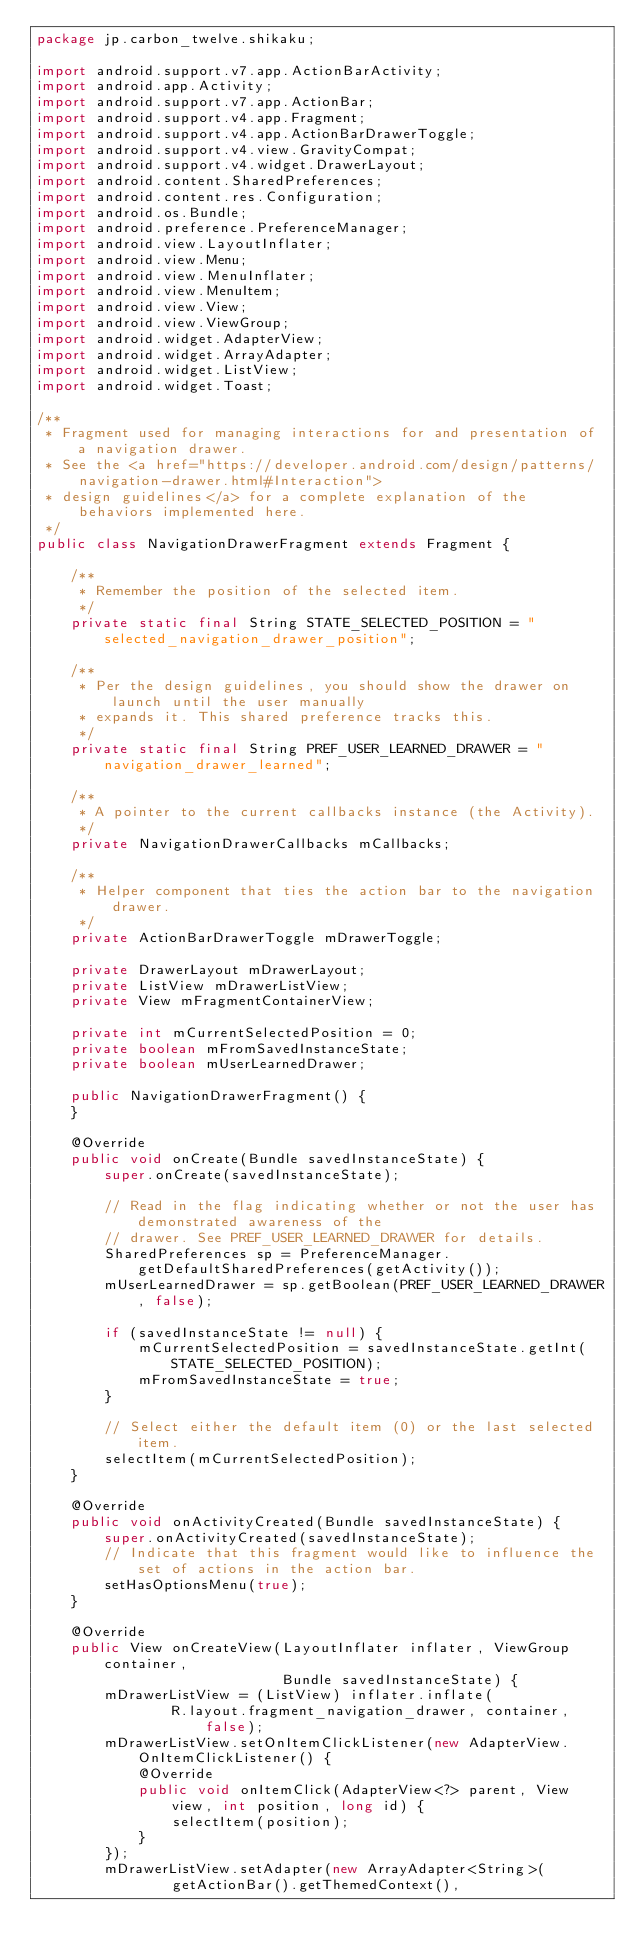Convert code to text. <code><loc_0><loc_0><loc_500><loc_500><_Java_>package jp.carbon_twelve.shikaku;

import android.support.v7.app.ActionBarActivity;
import android.app.Activity;
import android.support.v7.app.ActionBar;
import android.support.v4.app.Fragment;
import android.support.v4.app.ActionBarDrawerToggle;
import android.support.v4.view.GravityCompat;
import android.support.v4.widget.DrawerLayout;
import android.content.SharedPreferences;
import android.content.res.Configuration;
import android.os.Bundle;
import android.preference.PreferenceManager;
import android.view.LayoutInflater;
import android.view.Menu;
import android.view.MenuInflater;
import android.view.MenuItem;
import android.view.View;
import android.view.ViewGroup;
import android.widget.AdapterView;
import android.widget.ArrayAdapter;
import android.widget.ListView;
import android.widget.Toast;

/**
 * Fragment used for managing interactions for and presentation of a navigation drawer.
 * See the <a href="https://developer.android.com/design/patterns/navigation-drawer.html#Interaction">
 * design guidelines</a> for a complete explanation of the behaviors implemented here.
 */
public class NavigationDrawerFragment extends Fragment {

    /**
     * Remember the position of the selected item.
     */
    private static final String STATE_SELECTED_POSITION = "selected_navigation_drawer_position";

    /**
     * Per the design guidelines, you should show the drawer on launch until the user manually
     * expands it. This shared preference tracks this.
     */
    private static final String PREF_USER_LEARNED_DRAWER = "navigation_drawer_learned";

    /**
     * A pointer to the current callbacks instance (the Activity).
     */
    private NavigationDrawerCallbacks mCallbacks;

    /**
     * Helper component that ties the action bar to the navigation drawer.
     */
    private ActionBarDrawerToggle mDrawerToggle;

    private DrawerLayout mDrawerLayout;
    private ListView mDrawerListView;
    private View mFragmentContainerView;

    private int mCurrentSelectedPosition = 0;
    private boolean mFromSavedInstanceState;
    private boolean mUserLearnedDrawer;

    public NavigationDrawerFragment() {
    }

    @Override
    public void onCreate(Bundle savedInstanceState) {
        super.onCreate(savedInstanceState);

        // Read in the flag indicating whether or not the user has demonstrated awareness of the
        // drawer. See PREF_USER_LEARNED_DRAWER for details.
        SharedPreferences sp = PreferenceManager.getDefaultSharedPreferences(getActivity());
        mUserLearnedDrawer = sp.getBoolean(PREF_USER_LEARNED_DRAWER, false);

        if (savedInstanceState != null) {
            mCurrentSelectedPosition = savedInstanceState.getInt(STATE_SELECTED_POSITION);
            mFromSavedInstanceState = true;
        }

        // Select either the default item (0) or the last selected item.
        selectItem(mCurrentSelectedPosition);
    }

    @Override
    public void onActivityCreated(Bundle savedInstanceState) {
        super.onActivityCreated(savedInstanceState);
        // Indicate that this fragment would like to influence the set of actions in the action bar.
        setHasOptionsMenu(true);
    }

    @Override
    public View onCreateView(LayoutInflater inflater, ViewGroup container,
                             Bundle savedInstanceState) {
        mDrawerListView = (ListView) inflater.inflate(
                R.layout.fragment_navigation_drawer, container, false);
        mDrawerListView.setOnItemClickListener(new AdapterView.OnItemClickListener() {
            @Override
            public void onItemClick(AdapterView<?> parent, View view, int position, long id) {
                selectItem(position);
            }
        });
        mDrawerListView.setAdapter(new ArrayAdapter<String>(
                getActionBar().getThemedContext(),</code> 